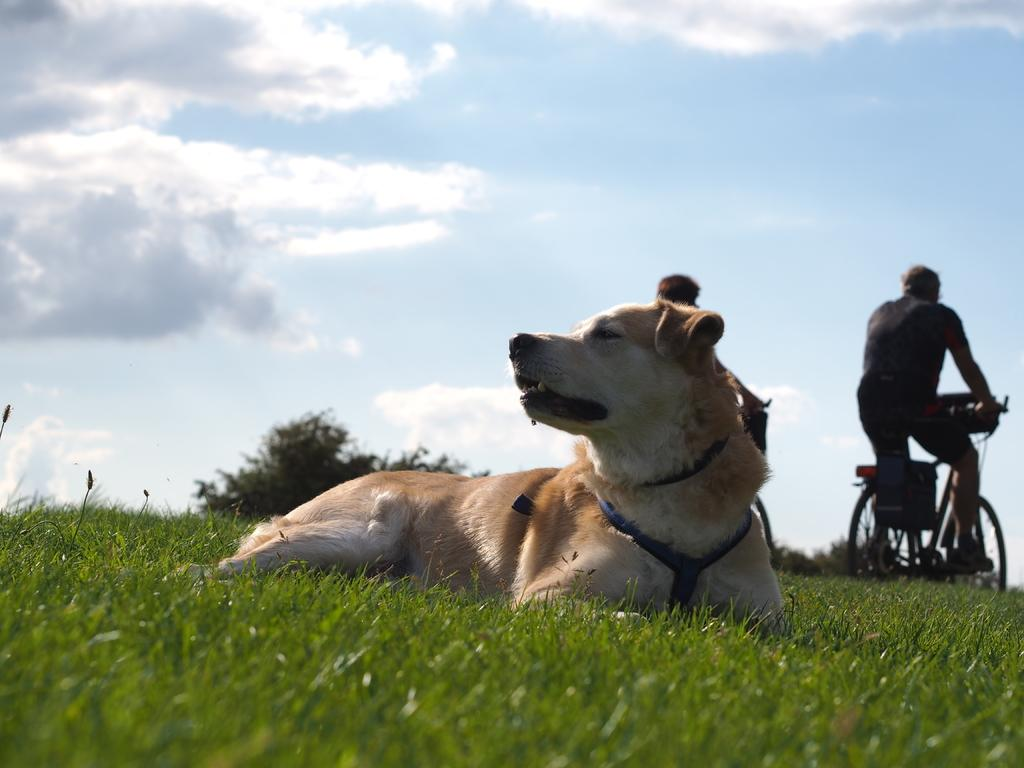What animal is on the ground in the image? There is a dog on the ground in the image. What type of surface is the dog on? There is grass on the ground. What activity can be seen in the background of the image? Two persons are riding bicycles in the background. What type of vegetation is visible in the background? There are trees in the background. What can be seen in the sky in the image? The sky is visible with clouds. What type of scissors is the dog using to cut the grass in the image? There are no scissors present in the image, and the dog is not cutting the grass. 